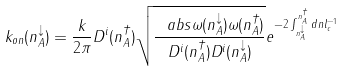Convert formula to latex. <formula><loc_0><loc_0><loc_500><loc_500>k _ { o n } ( n ^ { \downarrow } _ { A } ) = \frac { k } { 2 \pi } D ^ { i } ( n ^ { \dagger } _ { A } ) \sqrt { \frac { \ a b s { \omega ( n ^ { \downarrow } _ { A } ) \omega ( n ^ { \dagger } _ { A } ) } } { D ^ { i } ( n ^ { \dagger } _ { A } ) D ^ { i } ( n ^ { \downarrow } _ { A } ) } } e ^ { - 2 \int _ { n ^ { \downarrow } _ { A } } ^ { n ^ { \dagger } _ { A } } d n l _ { c } ^ { - 1 } }</formula> 